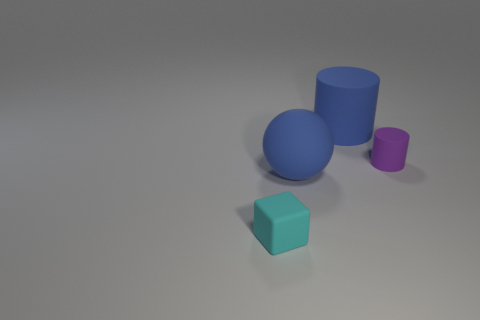Is there any other thing that is the same material as the small purple cylinder?
Your answer should be compact. Yes. Are any blue cylinders visible?
Give a very brief answer. Yes. Is the color of the tiny cylinder the same as the large matte thing that is in front of the blue matte cylinder?
Offer a terse response. No. There is a object that is to the left of the blue matte thing in front of the blue object that is on the right side of the large rubber ball; what is its size?
Keep it short and to the point. Small. What number of matte spheres have the same color as the large cylinder?
Your answer should be very brief. 1. How many things are either purple objects or small matte things behind the matte ball?
Keep it short and to the point. 1. The sphere is what color?
Offer a very short reply. Blue. There is a matte cylinder in front of the blue cylinder; what color is it?
Make the answer very short. Purple. How many big blue matte cylinders are behind the block on the left side of the small purple matte cylinder?
Offer a terse response. 1. There is a blue cylinder; does it have the same size as the object that is to the left of the rubber sphere?
Make the answer very short. No. 